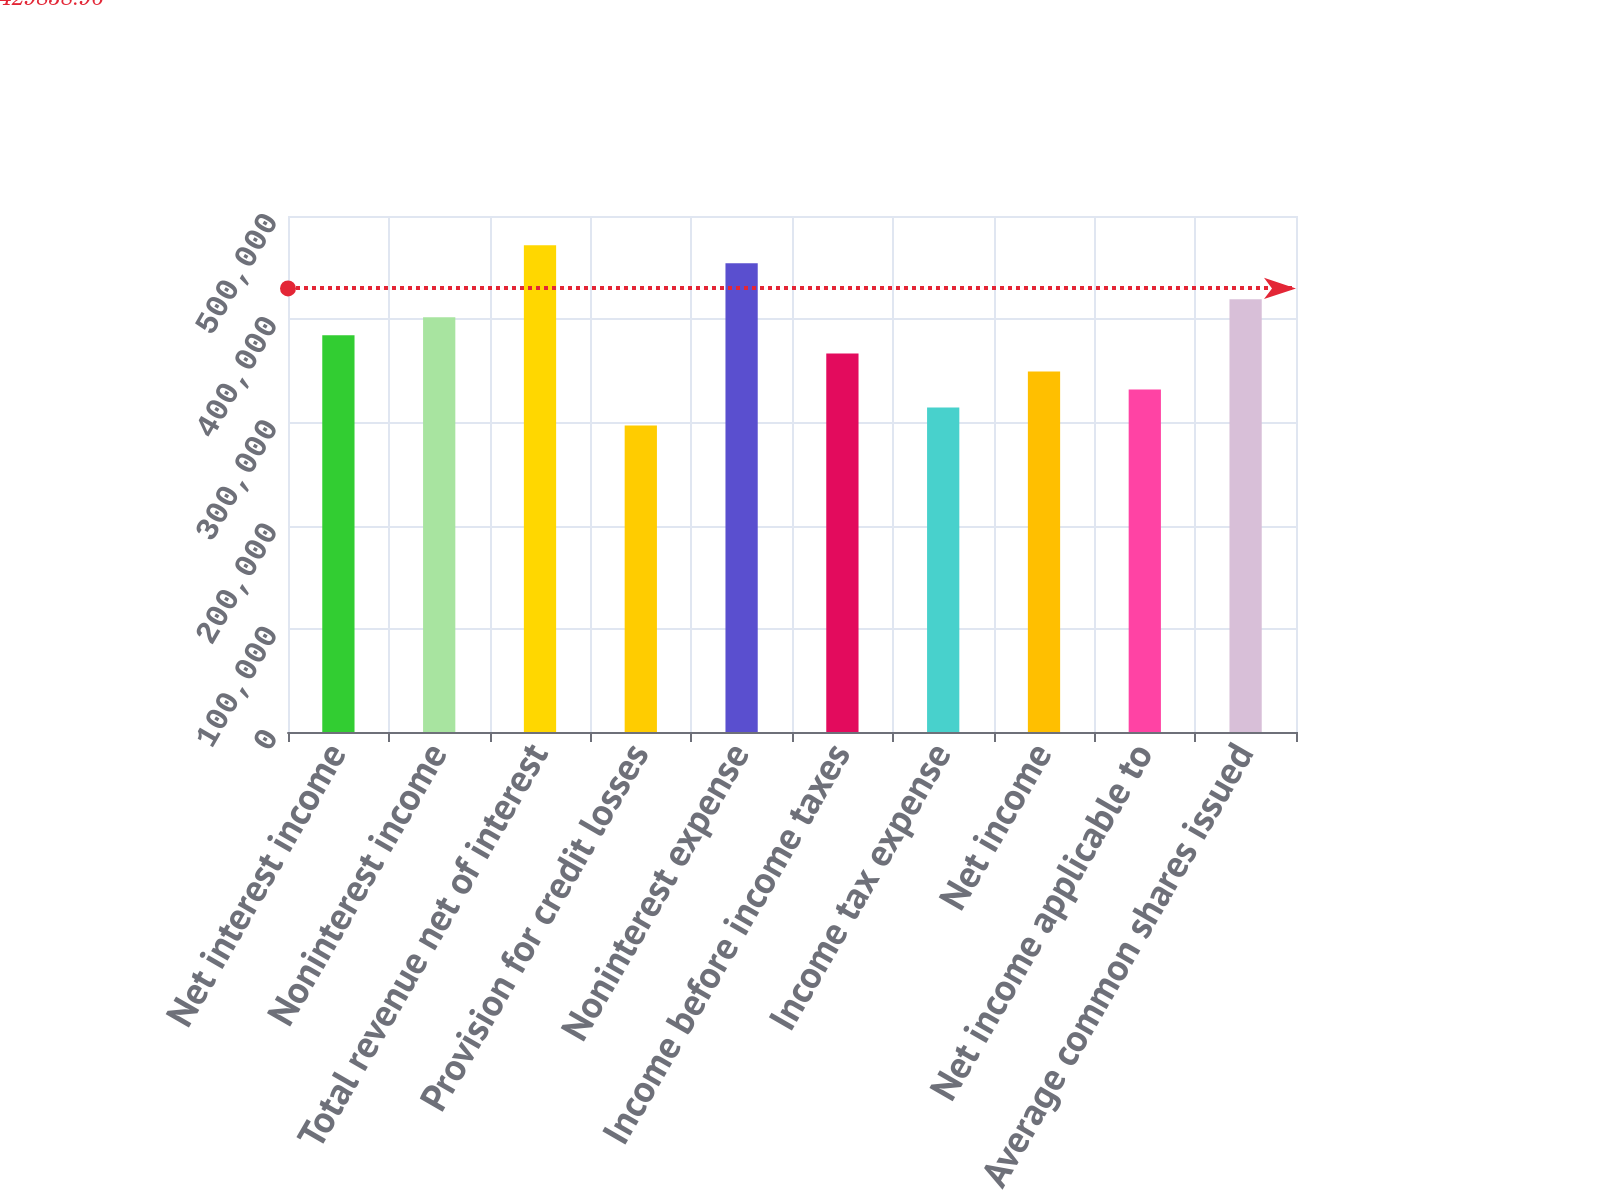Convert chart to OTSL. <chart><loc_0><loc_0><loc_500><loc_500><bar_chart><fcel>Net interest income<fcel>Noninterest income<fcel>Total revenue net of interest<fcel>Provision for credit losses<fcel>Noninterest expense<fcel>Income before income taxes<fcel>Income tax expense<fcel>Net income<fcel>Net income applicable to<fcel>Average common shares issued<nl><fcel>384340<fcel>401810<fcel>471690<fcel>296990<fcel>454220<fcel>366870<fcel>314460<fcel>349400<fcel>331930<fcel>419280<nl></chart> 